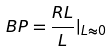Convert formula to latex. <formula><loc_0><loc_0><loc_500><loc_500>B P = \frac { R L } { L } | _ { L \approx 0 }</formula> 